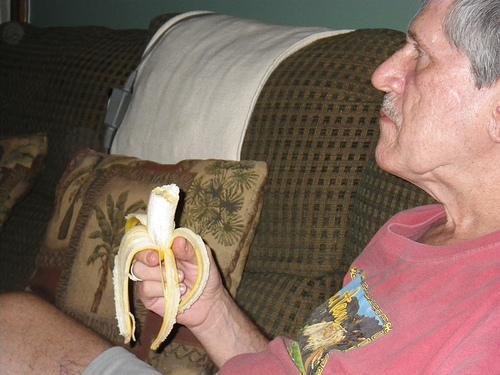How many pillows can you see?
Give a very brief answer. 2. 